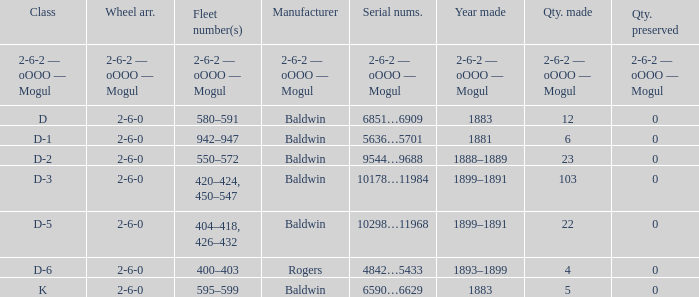What is the quantity made when the wheel arrangement is 2-6-0 and the class is k? 5.0. 